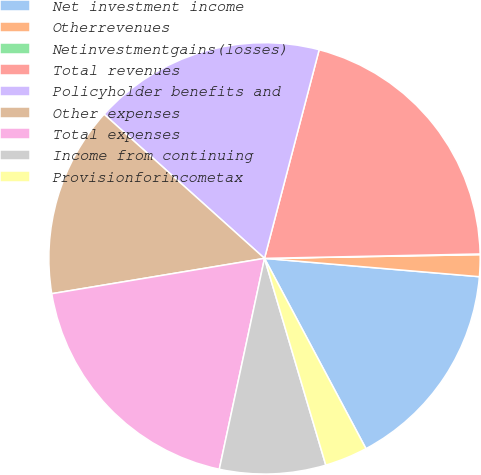Convert chart to OTSL. <chart><loc_0><loc_0><loc_500><loc_500><pie_chart><fcel>Net investment income<fcel>Otherrevenues<fcel>Netinvestmentgains(losses)<fcel>Total revenues<fcel>Policyholder benefits and<fcel>Other expenses<fcel>Total expenses<fcel>Income from continuing<fcel>Provisionforincometax<nl><fcel>15.85%<fcel>1.63%<fcel>0.05%<fcel>20.6%<fcel>17.43%<fcel>14.27%<fcel>19.02%<fcel>7.95%<fcel>3.21%<nl></chart> 